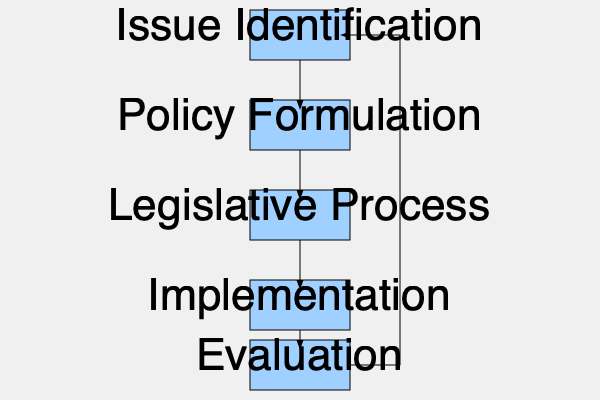In the flowchart illustrating the policy-making process in a secular government system, which stage ensures that the implemented policies align with the intended goals and societal needs, potentially leading to the identification of new issues? To answer this question, let's analyze the flowchart step-by-step:

1. The flowchart shows five main stages in the policy-making process: Issue Identification, Policy Formulation, Legislative Process, Implementation, and Evaluation.

2. The stages are connected in a linear fashion, with an additional feedback loop from the last stage to the first.

3. Issue Identification is the starting point, where societal problems or needs are recognized.

4. Policy Formulation follows, where potential solutions are developed.

5. The Legislative Process involves turning the proposed policy into law.

6. Implementation is the stage where the policy is put into action.

7. The final stage is Evaluation, which assesses the effectiveness and outcomes of the implemented policy.

8. There is a feedback loop from Evaluation back to Issue Identification, indicating that the results of the evaluation can lead to the identification of new issues or the need for policy adjustments.

9. The question asks about the stage that ensures alignment with goals and societal needs, potentially leading to new issue identification.

10. The Evaluation stage fulfills this role by assessing the policy's effectiveness and providing feedback that can initiate a new cycle of policy-making.

Therefore, the stage that ensures implemented policies align with intended goals and societal needs, potentially leading to the identification of new issues, is the Evaluation stage.
Answer: Evaluation 